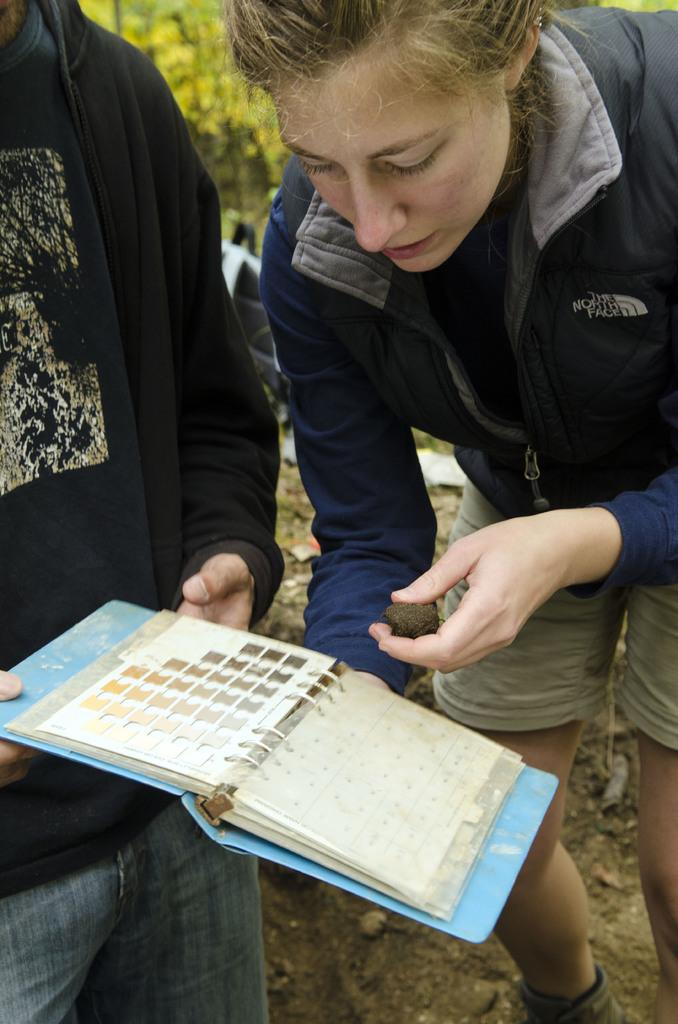How many people are present in the image? There are two people standing in the image. What is one person holding in the image? One person is holding a book. What is the other person holding in the image? The other person is holding an object. What can be seen in the background behind the people? There are trees and some objects visible behind the people. What type of roof can be seen on the house in the image? There is no house or roof present in the image. What is the father doing in the image? There is no mention of a father or any specific family relationship in the image. 